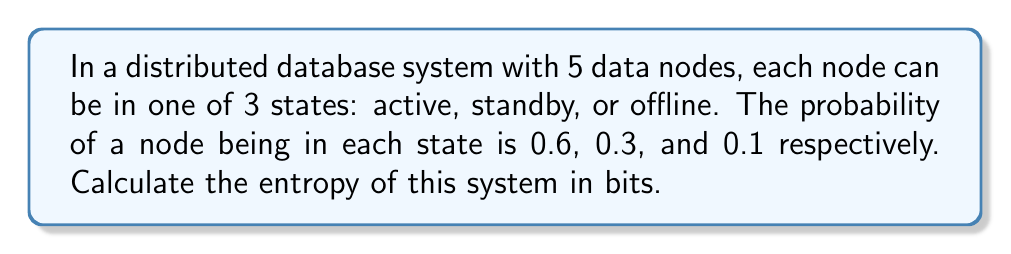Solve this math problem. To calculate the entropy of this distributed system, we'll follow these steps:

1. Recall the formula for entropy in bits:
   $$H = -\sum_{i=1}^{n} p_i \log_2(p_i)$$
   where $p_i$ is the probability of each state.

2. Identify the probabilities:
   $p_1 = 0.6$ (active)
   $p_2 = 0.3$ (standby)
   $p_3 = 0.1$ (offline)

3. Calculate each term in the sum:
   $$-0.6 \log_2(0.6) = 0.442$$
   $$-0.3 \log_2(0.3) = 0.521$$
   $$-0.1 \log_2(0.1) = 0.332$$

4. Sum the terms:
   $$H = 0.442 + 0.521 + 0.332 = 1.295$$

5. This is the entropy for a single node. Since there are 5 independent nodes, and entropy is additive for independent systems, multiply by 5:
   $$H_{total} = 5 \times 1.295 = 6.475$$

Thus, the total entropy of the system is approximately 6.475 bits.
Answer: 6.475 bits 